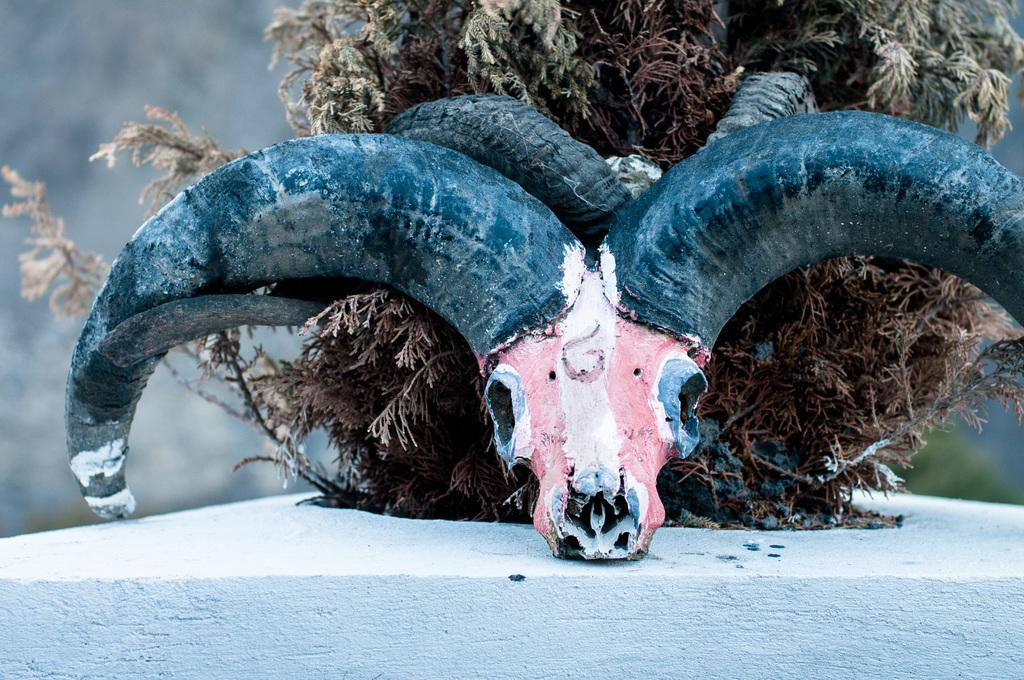What type of animal's skull is present in the image? There is a sheep's skull in the image. What other living organism can be seen in the image? There is a plant in the image. What type of lift is present in the image? There is no lift present in the image; it only features a sheep's skull and a plant. What color is the copper in the image? There is no copper present in the image. 